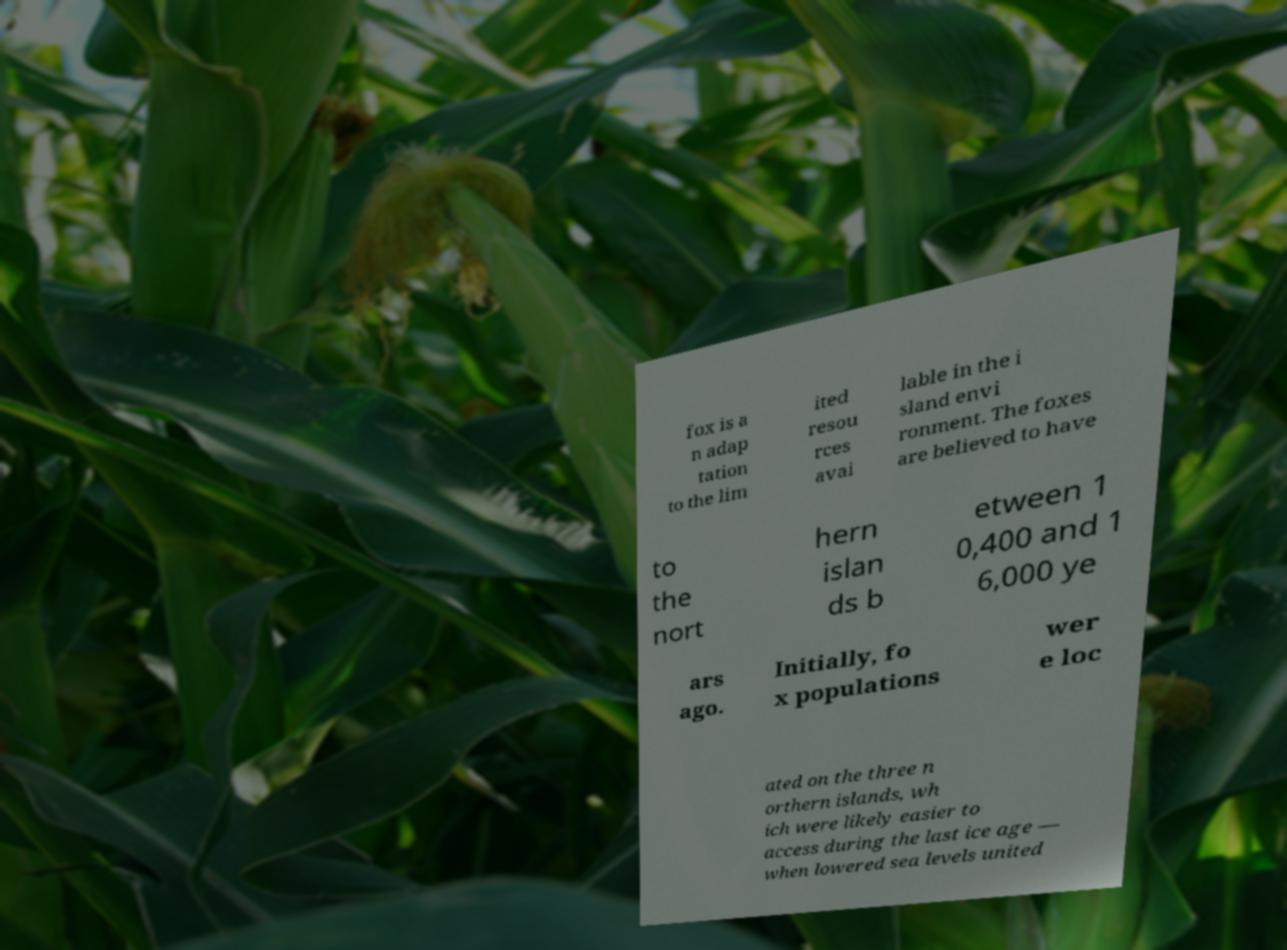I need the written content from this picture converted into text. Can you do that? fox is a n adap tation to the lim ited resou rces avai lable in the i sland envi ronment. The foxes are believed to have to the nort hern islan ds b etween 1 0,400 and 1 6,000 ye ars ago. Initially, fo x populations wer e loc ated on the three n orthern islands, wh ich were likely easier to access during the last ice age — when lowered sea levels united 